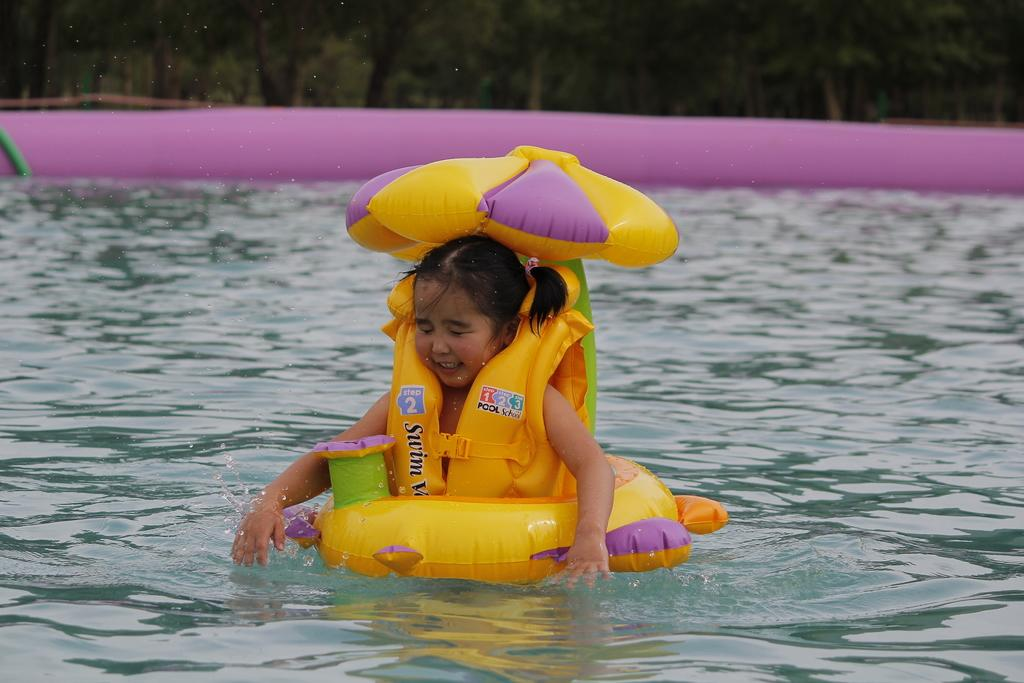Who is present in the image? There is a girl in the image. What is the girl doing in the image? The girl is swimming in the water. What object does the girl have in the image? The girl has a balloon. What can be seen in the background of the image? There is water and trees visible in the background of the image. What type of crime is being committed in the image? There is no crime being committed in the image; it features a girl swimming with a balloon. How does the image promote harmony among different species? The image does not depict any interaction between different species, so it cannot be said to promote harmony among them. 